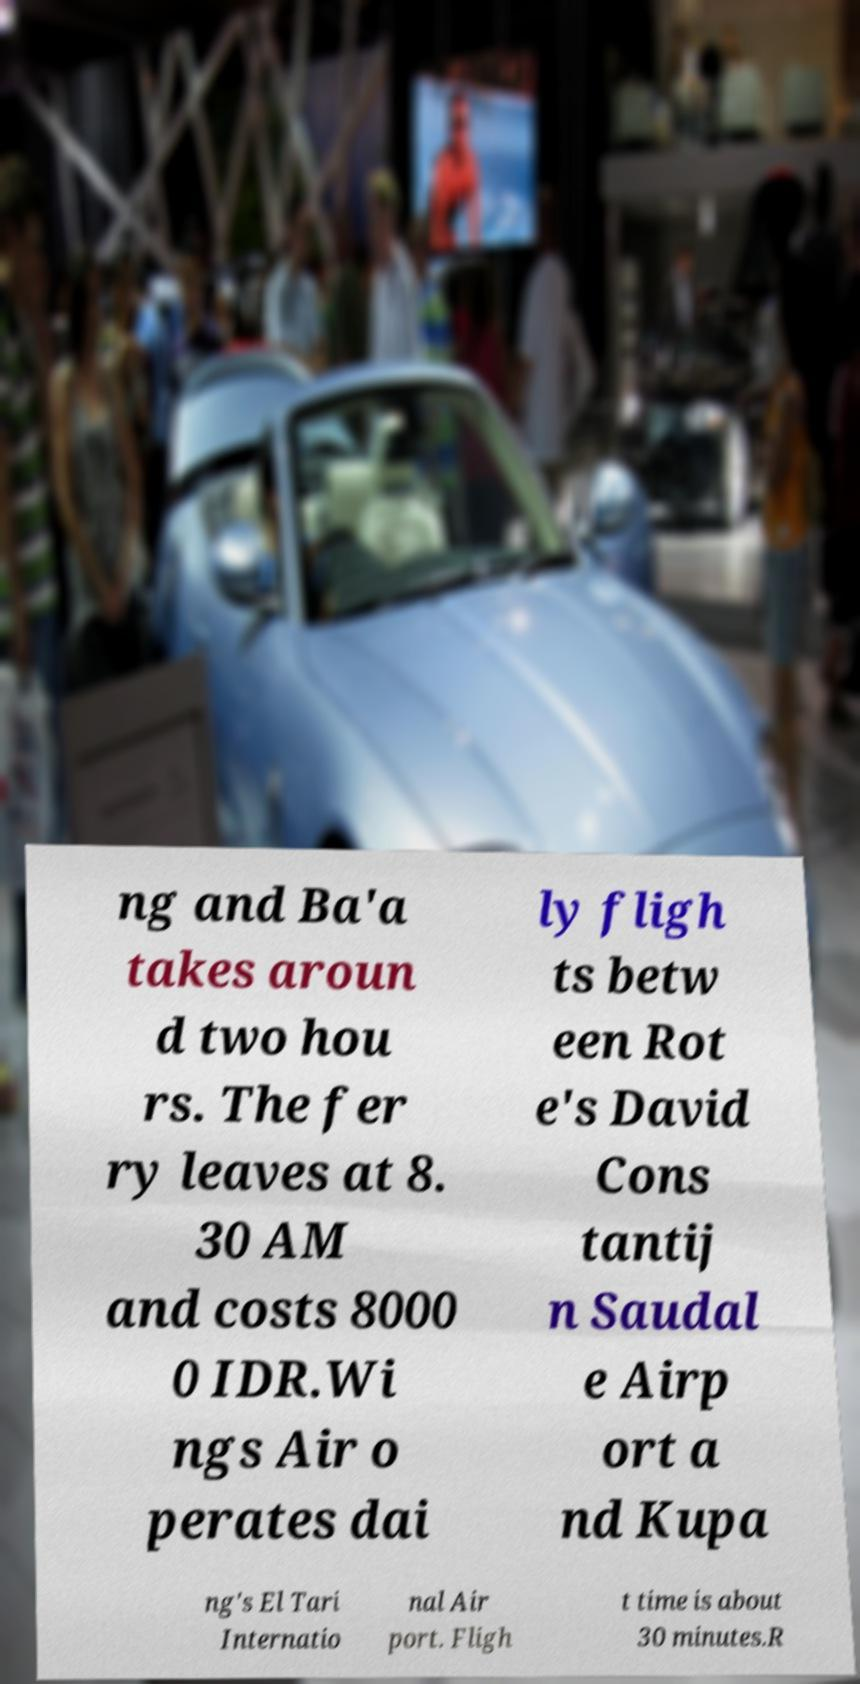I need the written content from this picture converted into text. Can you do that? ng and Ba'a takes aroun d two hou rs. The fer ry leaves at 8. 30 AM and costs 8000 0 IDR.Wi ngs Air o perates dai ly fligh ts betw een Rot e's David Cons tantij n Saudal e Airp ort a nd Kupa ng's El Tari Internatio nal Air port. Fligh t time is about 30 minutes.R 